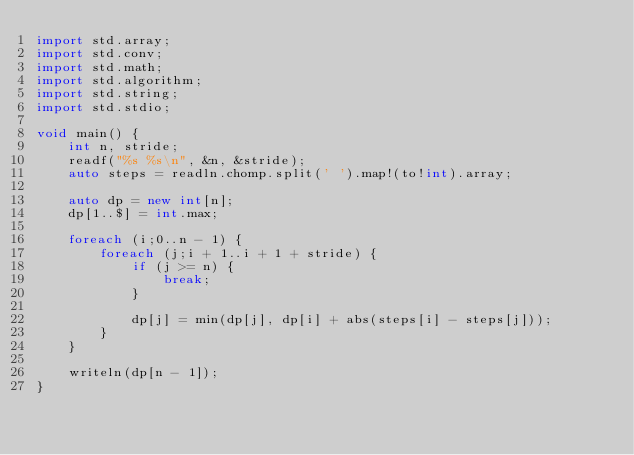<code> <loc_0><loc_0><loc_500><loc_500><_D_>import std.array;
import std.conv;
import std.math;
import std.algorithm;
import std.string;
import std.stdio;

void main() {
	int n, stride;
	readf("%s %s\n", &n, &stride);
	auto steps = readln.chomp.split(' ').map!(to!int).array;

	auto dp = new int[n];
	dp[1..$] = int.max;

	foreach (i;0..n - 1) {
		foreach (j;i + 1..i + 1 + stride) {
			if (j >= n) {
				break;
			}

			dp[j] = min(dp[j], dp[i] + abs(steps[i] - steps[j]));
		}
	}

	writeln(dp[n - 1]);
}
</code> 